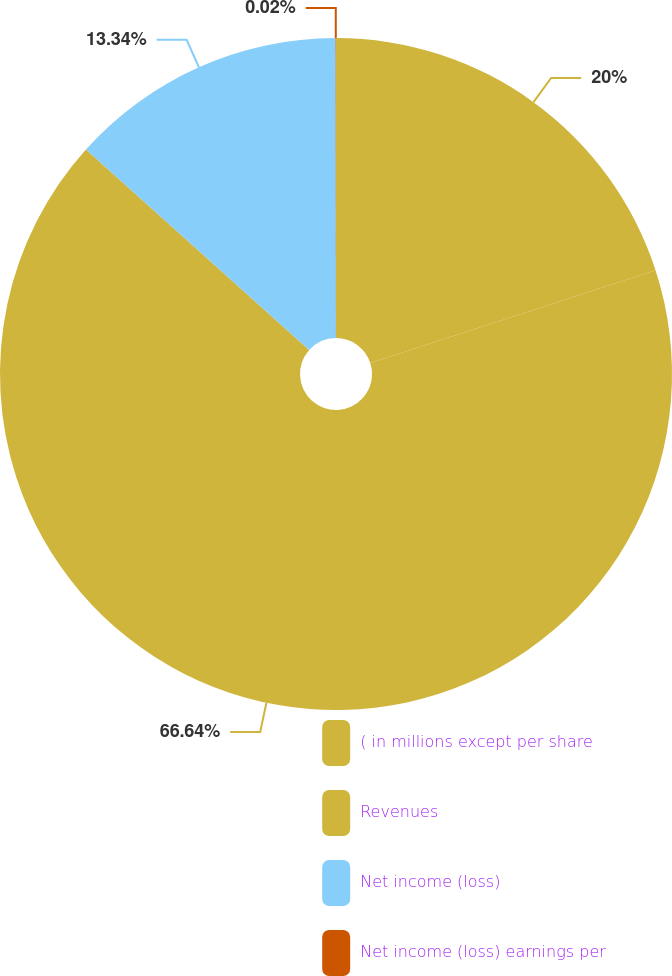Convert chart to OTSL. <chart><loc_0><loc_0><loc_500><loc_500><pie_chart><fcel>( in millions except per share<fcel>Revenues<fcel>Net income (loss)<fcel>Net income (loss) earnings per<nl><fcel>20.0%<fcel>66.64%<fcel>13.34%<fcel>0.02%<nl></chart> 